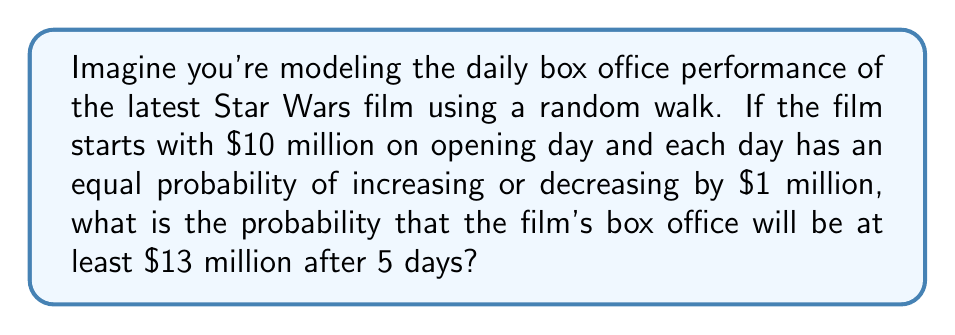Give your solution to this math problem. Let's approach this step-by-step:

1) This scenario can be modeled as a simple symmetric random walk, where:
   - The initial position is $S_0 = 10$ (million dollars)
   - Each step is either +1 or -1 with equal probability
   - We want to find $P(S_5 \geq 13)$

2) To reach $13 million or more after 5 days, the walk needs to have at least 3 more ups than downs.

3) The possible outcomes after 5 days that satisfy this condition are:
   - 4 ups, 1 down (net +3)
   - 5 ups, 0 downs (net +5)

4) We can calculate the probability of each of these outcomes:

   For 4 ups, 1 down:
   $$P(4\text{ ups}, 1\text{ down}) = \binom{5}{4} \cdot (0.5)^5 = 5 \cdot (0.5)^5 = \frac{5}{32}$$

   For 5 ups, 0 downs:
   $$P(5\text{ ups}, 0\text{ downs}) = \binom{5}{5} \cdot (0.5)^5 = 1 \cdot (0.5)^5 = \frac{1}{32}$$

5) The total probability is the sum of these two probabilities:

   $$P(S_5 \geq 13) = \frac{5}{32} + \frac{1}{32} = \frac{6}{32} = \frac{3}{16}$$

Therefore, the probability that the film's box office will be at least $13 million after 5 days is $\frac{3}{16}$.
Answer: $\frac{3}{16}$ 